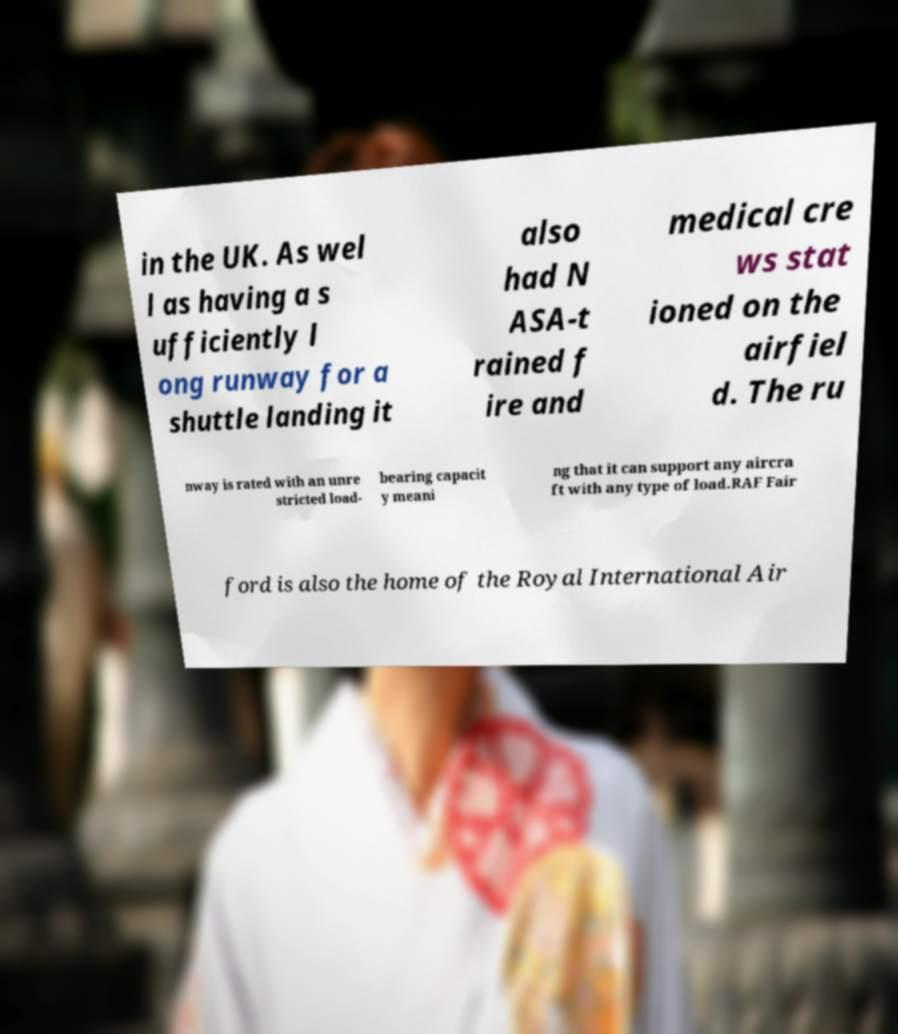Could you extract and type out the text from this image? in the UK. As wel l as having a s ufficiently l ong runway for a shuttle landing it also had N ASA-t rained f ire and medical cre ws stat ioned on the airfiel d. The ru nway is rated with an unre stricted load- bearing capacit y meani ng that it can support any aircra ft with any type of load.RAF Fair ford is also the home of the Royal International Air 